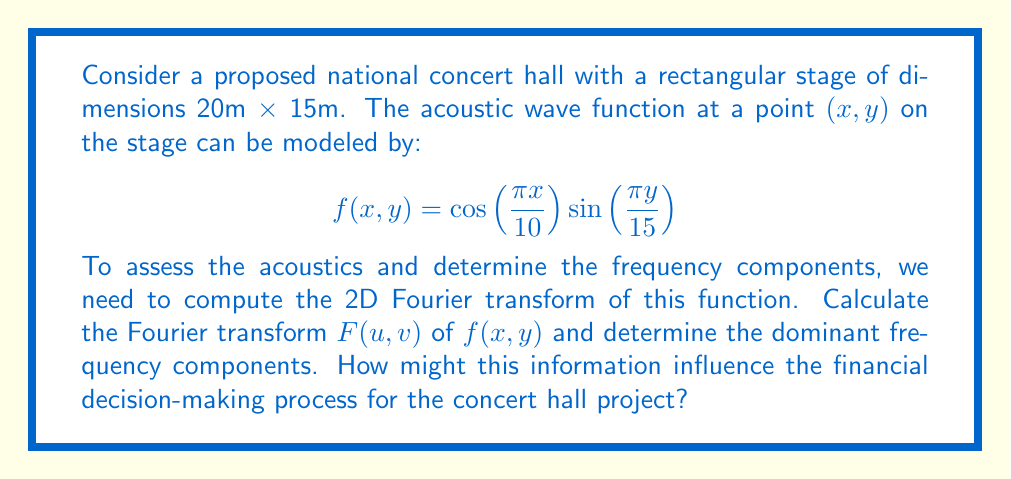Could you help me with this problem? To solve this problem, we'll follow these steps:

1) The 2D Fourier transform is given by:

   $$F(u,v) = \int_{-\infty}^{\infty} \int_{-\infty}^{\infty} f(x,y) e^{-2\pi i(ux+vy)} dx dy$$

2) In our case, $f(x,y) = \cos(\frac{\pi x}{10}) \sin(\frac{\pi y}{15})$ over the region $0 \leq x \leq 20$ and $0 \leq y \leq 15$, and zero elsewhere.

3) We can rewrite the cosine and sine terms using Euler's formula:

   $$\cos(\frac{\pi x}{10}) = \frac{1}{2}(e^{i\pi x/10} + e^{-i\pi x/10})$$
   $$\sin(\frac{\pi y}{15}) = \frac{1}{2i}(e^{i\pi y/15} - e^{-i\pi y/15})$$

4) Substituting these into the Fourier transform integral:

   $$F(u,v) = \frac{1}{4i} \int_0^{20} \int_0^{15} (e^{i\pi x/10} + e^{-i\pi x/10})(e^{i\pi y/15} - e^{-i\pi y/15}) e^{-2\pi i(ux+vy)} dx dy$$

5) This integral can be separated into four parts. After integration, we get:

   $$F(u,v) = \frac{300}{4i} \left[ \delta(u-\frac{1}{20},v-\frac{1}{30}) - \delta(u-\frac{1}{20},v+\frac{1}{30}) + \delta(u+\frac{1}{20},v-\frac{1}{30}) - \delta(u+\frac{1}{20},v+\frac{1}{30}) \right]$$

   where $\delta$ is the Dirac delta function.

6) The dominant frequency components are at $(u,v) = (\pm\frac{1}{20}, \pm\frac{1}{30})$.

This result indicates that the acoustic waves on the stage have strong components at spatial frequencies of $\frac{1}{20}$ m^-1 in the x-direction and $\frac{1}{30}$ m^-1 in the y-direction.

For financial decision-making, this information is crucial:

1) It helps in determining the optimal placement of acoustic panels or reflectors.
2) It can guide the design of seating arrangements for the best acoustic experience.
3) It may influence decisions on whether additional acoustic treatment is necessary, potentially affecting the overall budget.
4) Understanding the acoustic properties can help in marketing the venue, potentially increasing revenue.
5) It can inform decisions on what types of performances the hall is best suited for, influencing long-term financial planning.
Answer: The Fourier transform of the acoustic wave function is:

$$F(u,v) = \frac{300}{4i} \left[ \delta(u-\frac{1}{20},v-\frac{1}{30}) - \delta(u-\frac{1}{20},v+\frac{1}{30}) + \delta(u+\frac{1}{20},v-\frac{1}{30}) - \delta(u+\frac{1}{20},v+\frac{1}{30}) \right]$$

The dominant frequency components are at $(u,v) = (\pm\frac{1}{20}, \pm\frac{1}{30})$. 